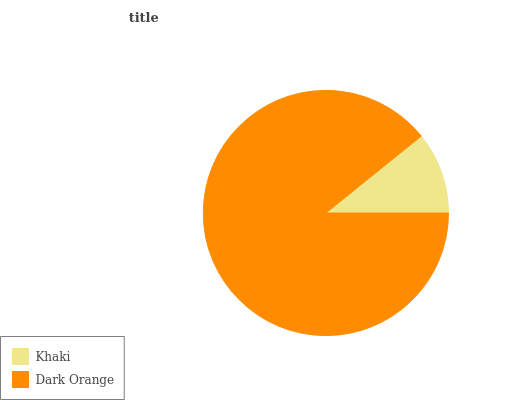Is Khaki the minimum?
Answer yes or no. Yes. Is Dark Orange the maximum?
Answer yes or no. Yes. Is Dark Orange the minimum?
Answer yes or no. No. Is Dark Orange greater than Khaki?
Answer yes or no. Yes. Is Khaki less than Dark Orange?
Answer yes or no. Yes. Is Khaki greater than Dark Orange?
Answer yes or no. No. Is Dark Orange less than Khaki?
Answer yes or no. No. Is Dark Orange the high median?
Answer yes or no. Yes. Is Khaki the low median?
Answer yes or no. Yes. Is Khaki the high median?
Answer yes or no. No. Is Dark Orange the low median?
Answer yes or no. No. 